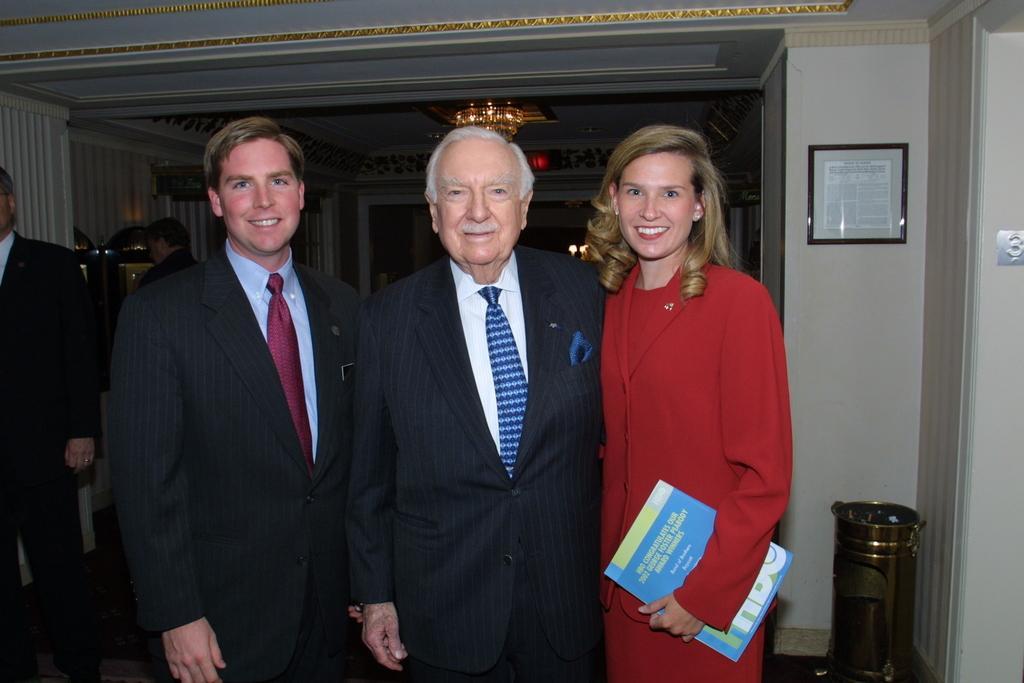Describe this image in one or two sentences. In this image, we can see three people are standing side by side. They are watching and smiling. Here a woman is holding a book. Background we can see walls, few objects, people, chandelier, lights and ceiling. On the right side bottom, we can see gold color object. 